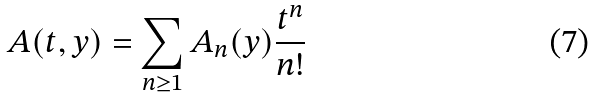<formula> <loc_0><loc_0><loc_500><loc_500>A ( t , y ) = \sum _ { n \geq 1 } A _ { n } ( y ) \frac { t ^ { n } } { n ! }</formula> 